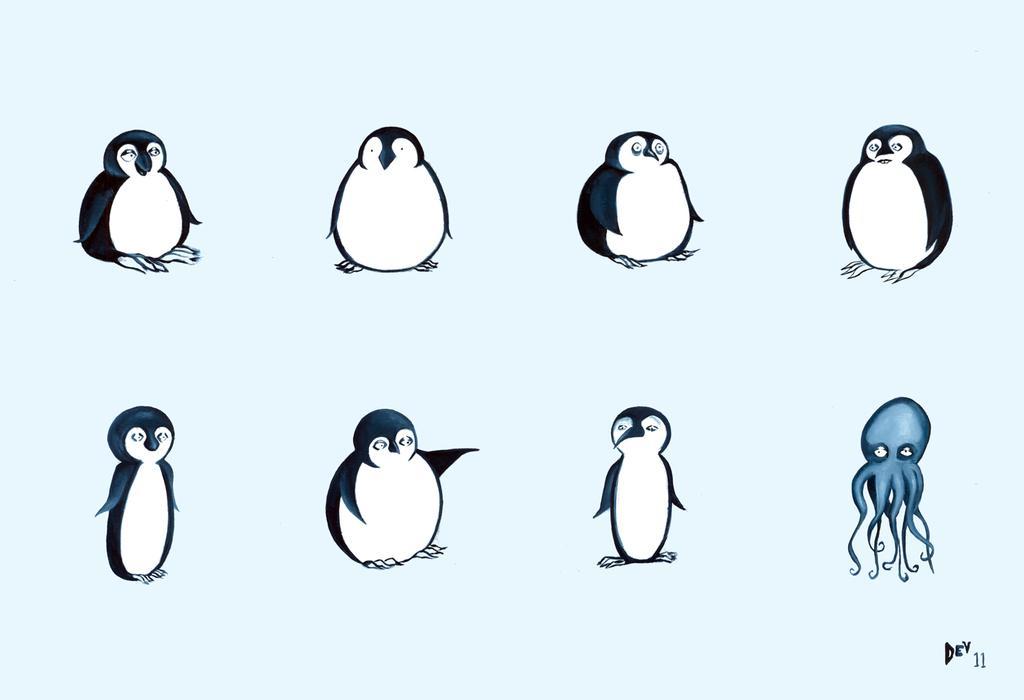How would you summarize this image in a sentence or two? This image consists of a poster with a few images of penguins and an octopus. 